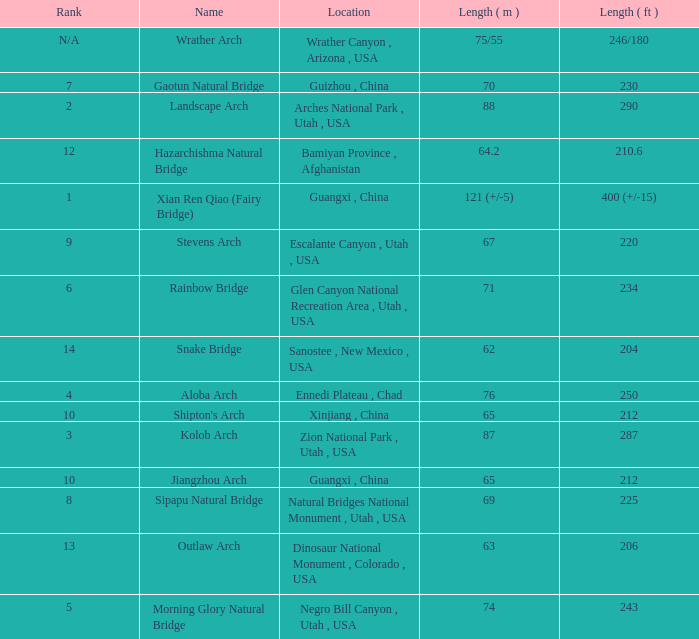What is the rank of the arch with a length in meters of 75/55? N/A. 